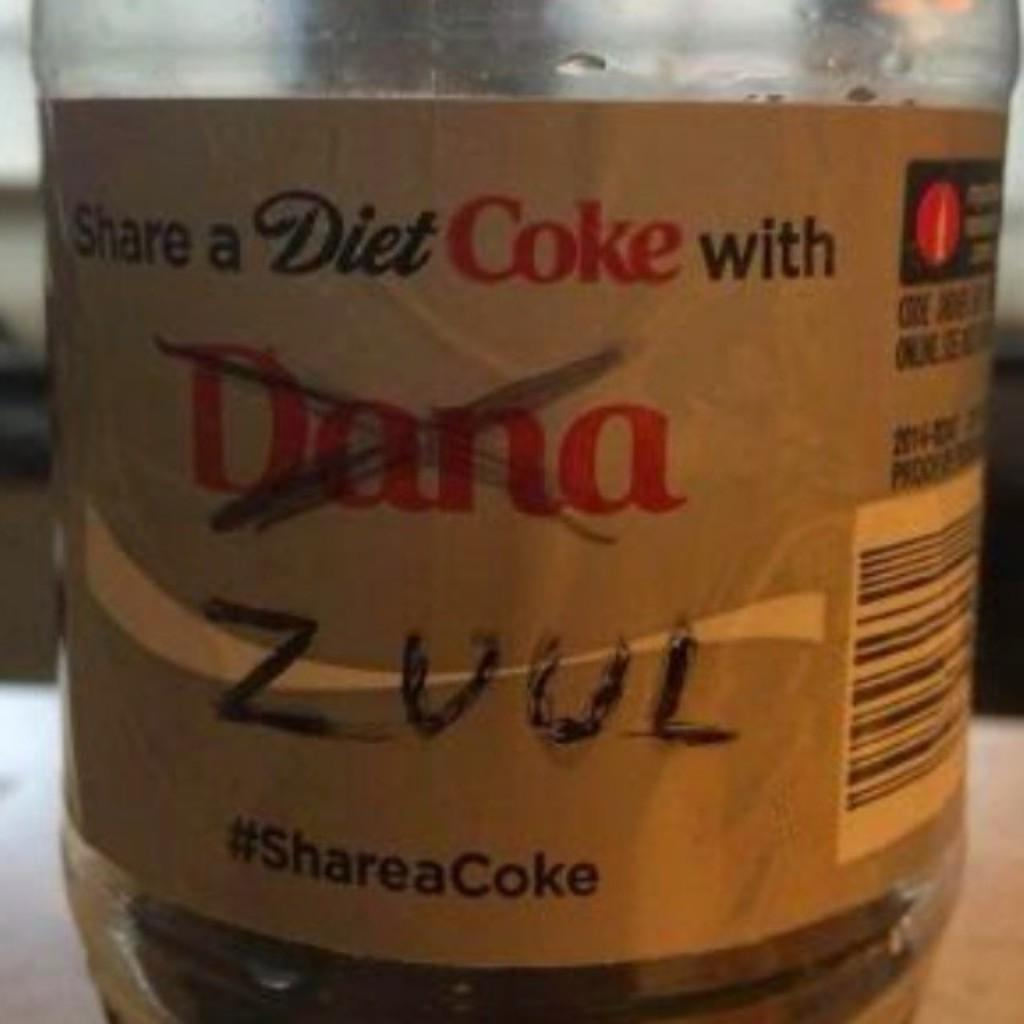<image>
Create a compact narrative representing the image presented. A diet coke with the name dana crossed out and zuul written in 